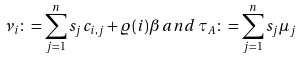<formula> <loc_0><loc_0><loc_500><loc_500>\nu _ { i } \colon = \sum _ { j = 1 } ^ { n } s _ { j } c _ { i , j } + \varrho ( i ) \beta \, a n d \, \tau _ { A } \colon = \sum _ { j = 1 } ^ { n } s _ { j } \mu _ { j }</formula> 